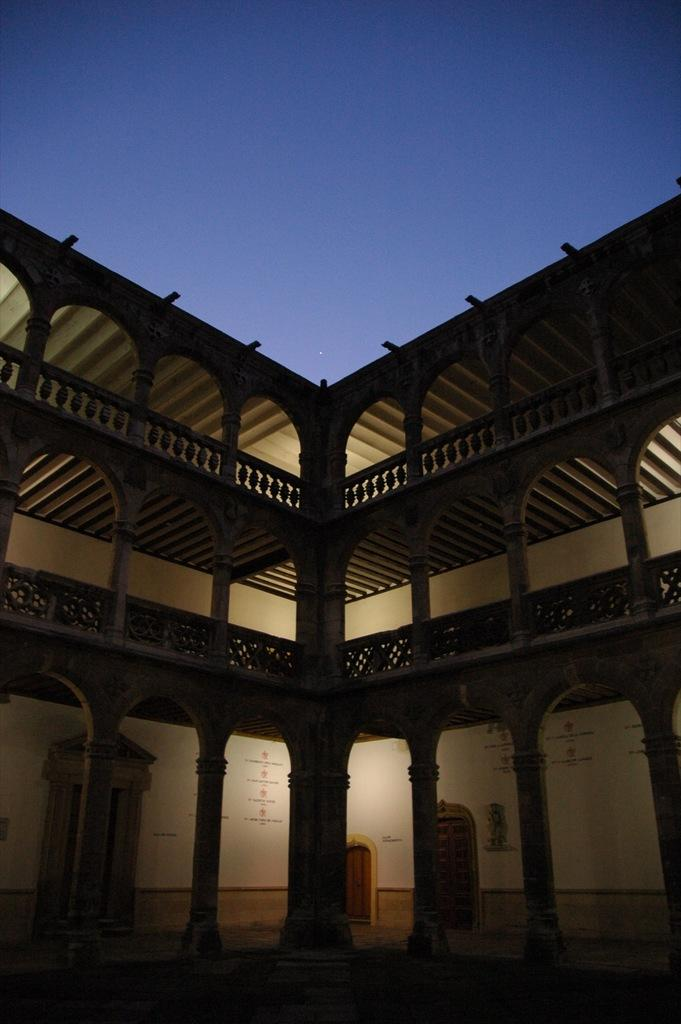What type of structure is present in the image? There is a building in the picture. What can be seen on the walls of the building? There is text on the walls of the building. How many doors are visible in the picture? There are doors visible in the picture. What is the color of the sky in the image? The sky is blue in the image. How many pens are visible in the image? There are no pens present in the image. What type of destruction is happening to the building in the image? There is no destruction happening to the building in the image; it appears to be intact. 